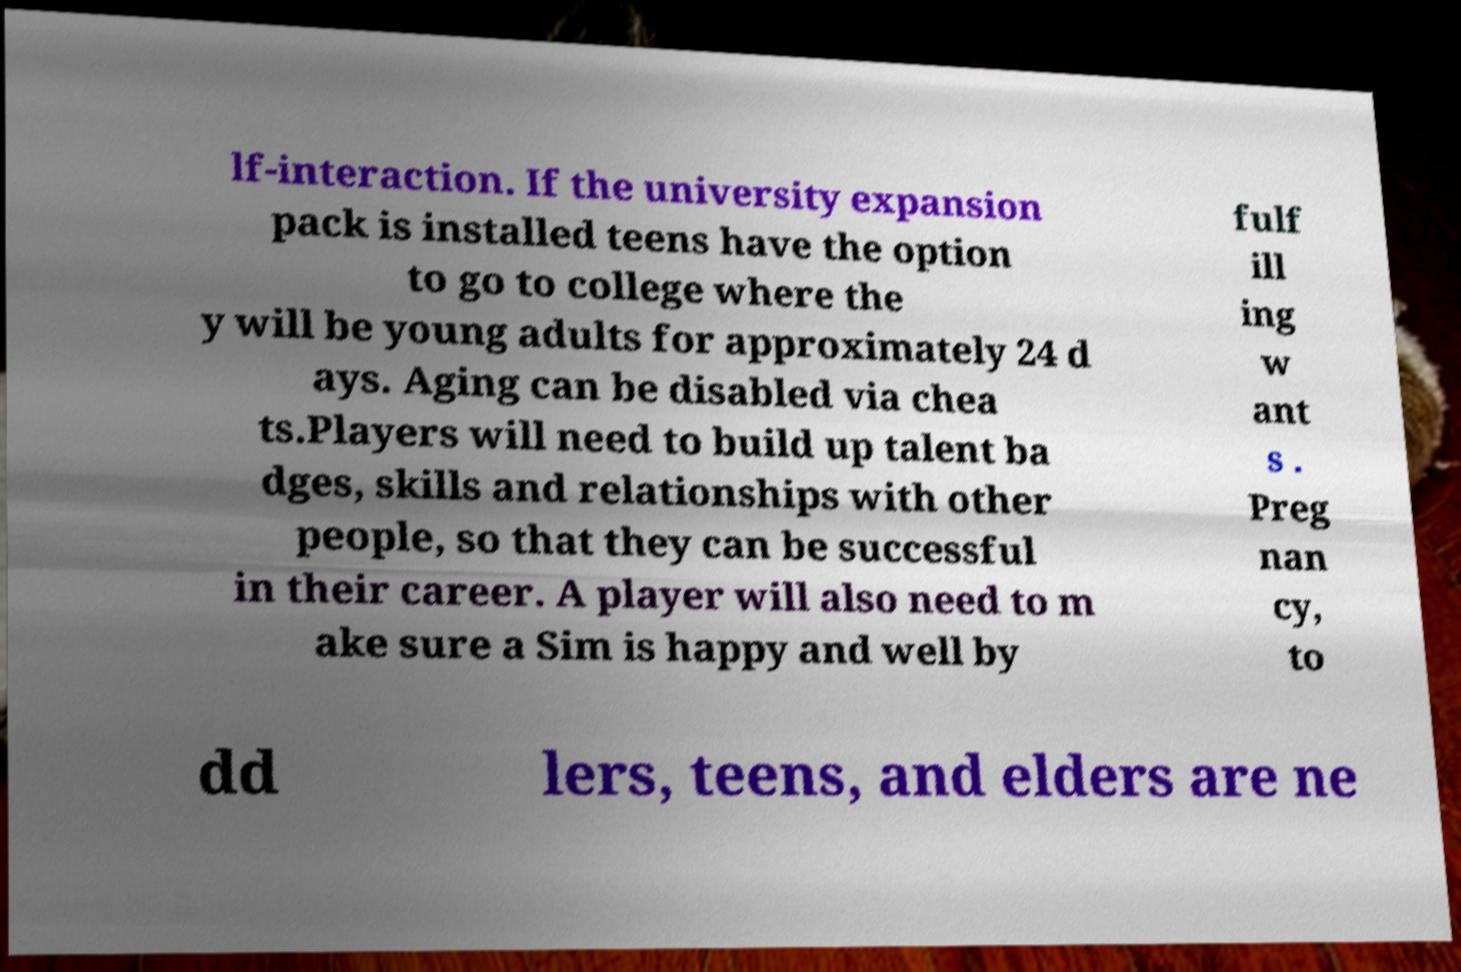Could you assist in decoding the text presented in this image and type it out clearly? lf-interaction. If the university expansion pack is installed teens have the option to go to college where the y will be young adults for approximately 24 d ays. Aging can be disabled via chea ts.Players will need to build up talent ba dges, skills and relationships with other people, so that they can be successful in their career. A player will also need to m ake sure a Sim is happy and well by fulf ill ing w ant s . Preg nan cy, to dd lers, teens, and elders are ne 